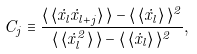<formula> <loc_0><loc_0><loc_500><loc_500>C _ { j } \equiv \frac { \langle \, \langle \dot { x } _ { l } \dot { x } _ { l + j } \rangle \, \rangle - \langle \, \langle \dot { x } _ { l } \rangle \, \rangle ^ { 2 } } { \langle \, \langle \dot { x } _ { l } ^ { 2 } \rangle \, \rangle - \langle \, \langle \dot { x } _ { l } \rangle \, \rangle ^ { 2 } } ,</formula> 